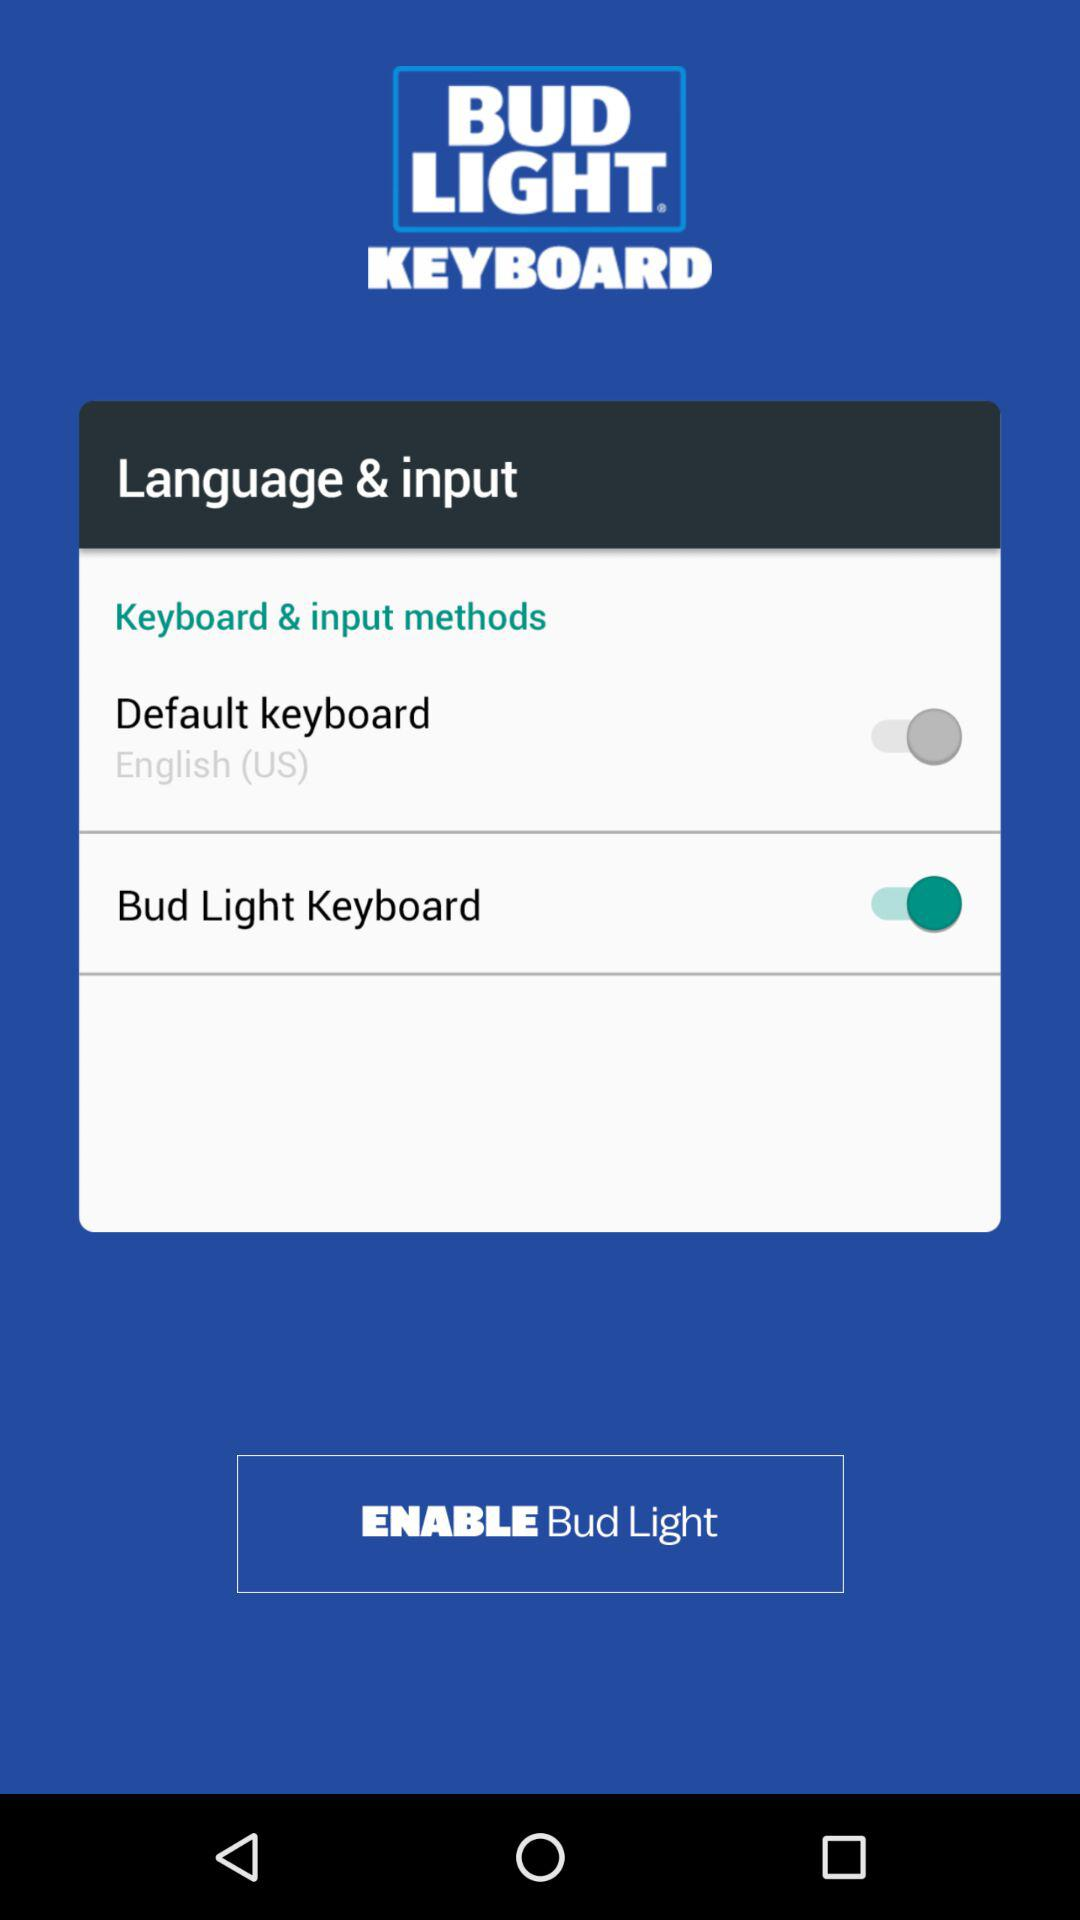What is the status of the "Bud Light Keyboard"? The status is "on". 